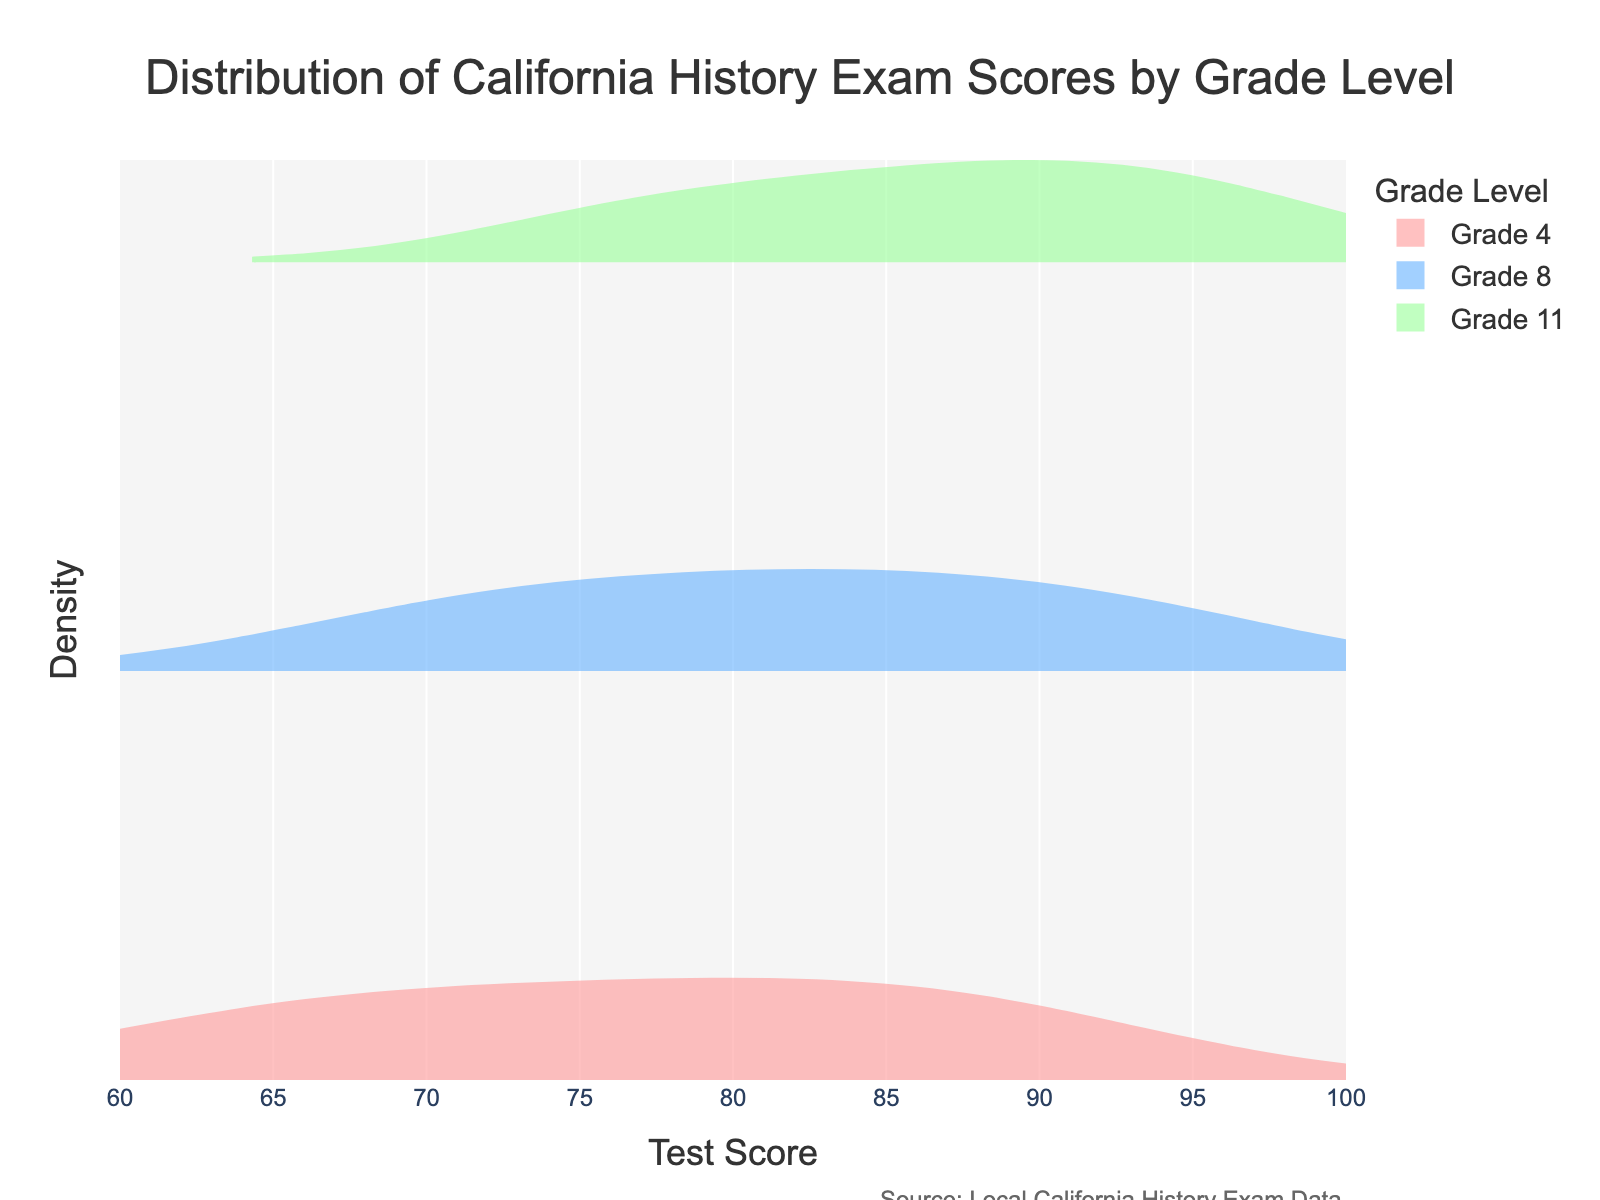What is the title of the plot? The title of the plot is usually located at the top and is in a larger font size compared to other texts. In this case, it reads "Distribution of California History Exam Scores by Grade Level."
Answer: Distribution of California History Exam Scores by Grade Level Which grade has the highest mean test score? To determine the grade with the highest mean test score, look for the meanline visible on each grade's density plot. The specific position of the meanline on the x-axis will indicate the average score for each grade.
Answer: Grade 11 What is the range of test scores shown on the x-axis? The x-axis range is displayed at the bottom of the chart, usually marked by the minimum and maximum values. It helps indicate the spread of data values.
Answer: 60 to 100 How many different grade levels are represented in the plot? The number of grade levels can be derived by counting the number of distinct colors and density plots within the legend and figure. Each color represents a different grade.
Answer: 3 Which grade shows the widest distribution of scores? The distribution width is represented by the spread of the density plot on the x-axis. The grade with the widest spread indicates the most variability in scores.
Answer: Grade 4 What is the color used for Grade 8? Each grade is represented by a specific color in the plot. Identifying the color associated with Grade 8 can be done by looking at the legend or directly at the density plot.
Answer: Blue Which grade has the lowest test score represented in their distribution? The lowest test score can be identified by finding the leftmost point within the density plot of each grade. Compare among grades to find the lowest score overall.
Answer: Grade 4 What is the density represented along the y-axis? Density on the y-axis represents how the scores are spread across different values on the x-axis. Although the values are not labeled, the shape indicates the concentration of scores.
Answer: Density Are the highest scores for Grade 8 better than the highest scores for Grade 4? Compare the maximum points on the x-axis for the density plots of Grade 8 and Grade 4 to see which grade has higher scores.
Answer: Yes Which grade level's distribution is closest to the mean score of 80? To find the grade whose distribution centers around a mean score of 80, look for the meanline of each grade that is nearest to the 80 point on the x-axis.
Answer: Grade 8 